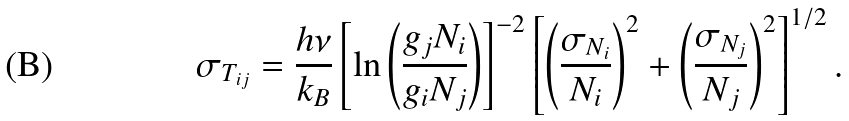Convert formula to latex. <formula><loc_0><loc_0><loc_500><loc_500>\sigma _ { T _ { i j } } = \frac { h \nu } { k _ { B } } \left [ \ln \left ( \frac { g _ { j } N _ { i } } { g _ { i } N _ { j } } \right ) \right ] ^ { - 2 } \left [ \left ( \frac { \sigma _ { N _ { i } } } { N _ { i } } \right ) ^ { 2 } + \left ( \frac { \sigma _ { N _ { j } } } { N _ { j } } \right ) ^ { 2 } \right ] ^ { 1 / 2 } .</formula> 